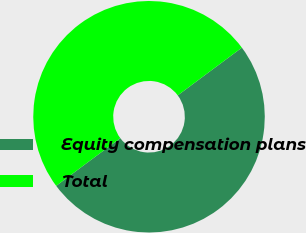<chart> <loc_0><loc_0><loc_500><loc_500><pie_chart><fcel>Equity compensation plans<fcel>Total<nl><fcel>50.0%<fcel>50.0%<nl></chart> 